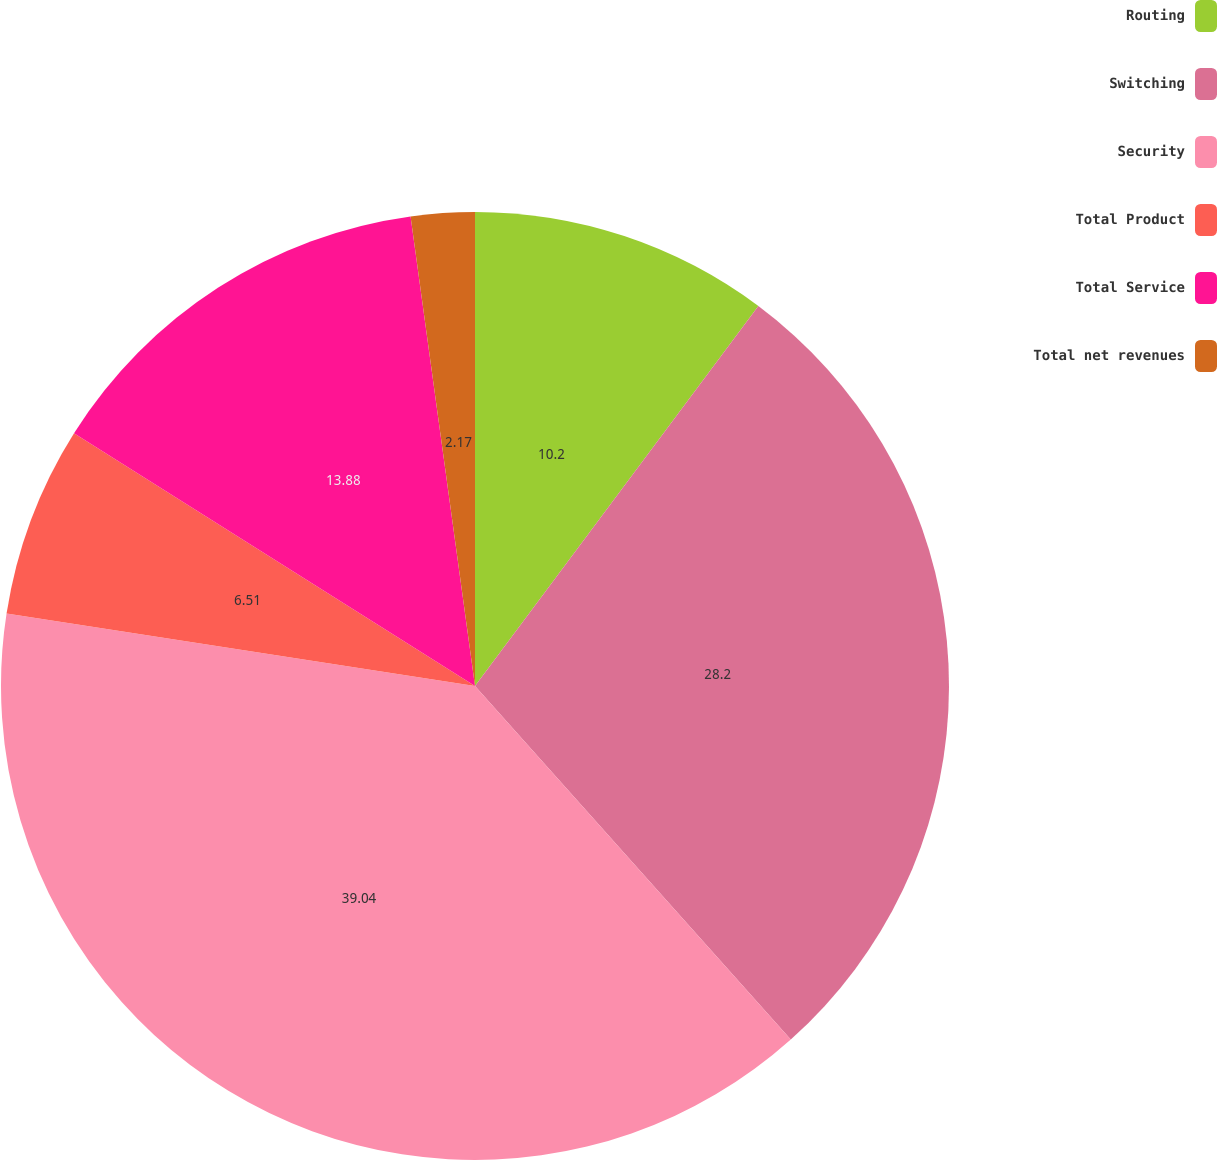Convert chart. <chart><loc_0><loc_0><loc_500><loc_500><pie_chart><fcel>Routing<fcel>Switching<fcel>Security<fcel>Total Product<fcel>Total Service<fcel>Total net revenues<nl><fcel>10.2%<fcel>28.2%<fcel>39.05%<fcel>6.51%<fcel>13.88%<fcel>2.17%<nl></chart> 